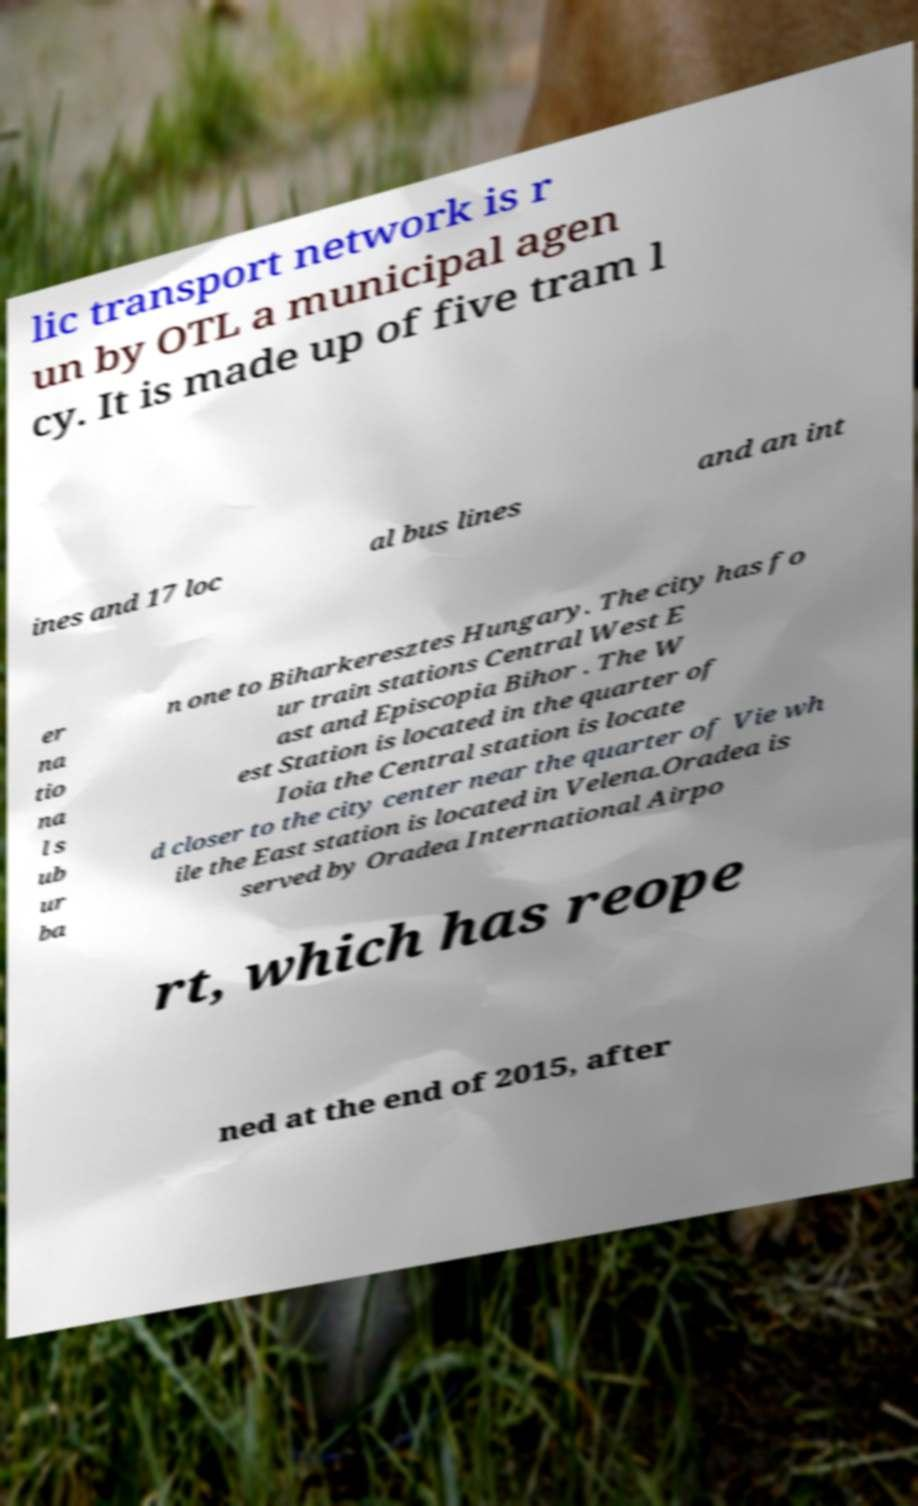Could you extract and type out the text from this image? lic transport network is r un by OTL a municipal agen cy. It is made up of five tram l ines and 17 loc al bus lines and an int er na tio na l s ub ur ba n one to Biharkeresztes Hungary. The city has fo ur train stations Central West E ast and Episcopia Bihor . The W est Station is located in the quarter of Ioia the Central station is locate d closer to the city center near the quarter of Vie wh ile the East station is located in Velena.Oradea is served by Oradea International Airpo rt, which has reope ned at the end of 2015, after 